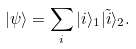Convert formula to latex. <formula><loc_0><loc_0><loc_500><loc_500>| \psi \rangle = \sum _ { i } | i \rangle _ { 1 } | \tilde { i } \rangle _ { 2 } .</formula> 